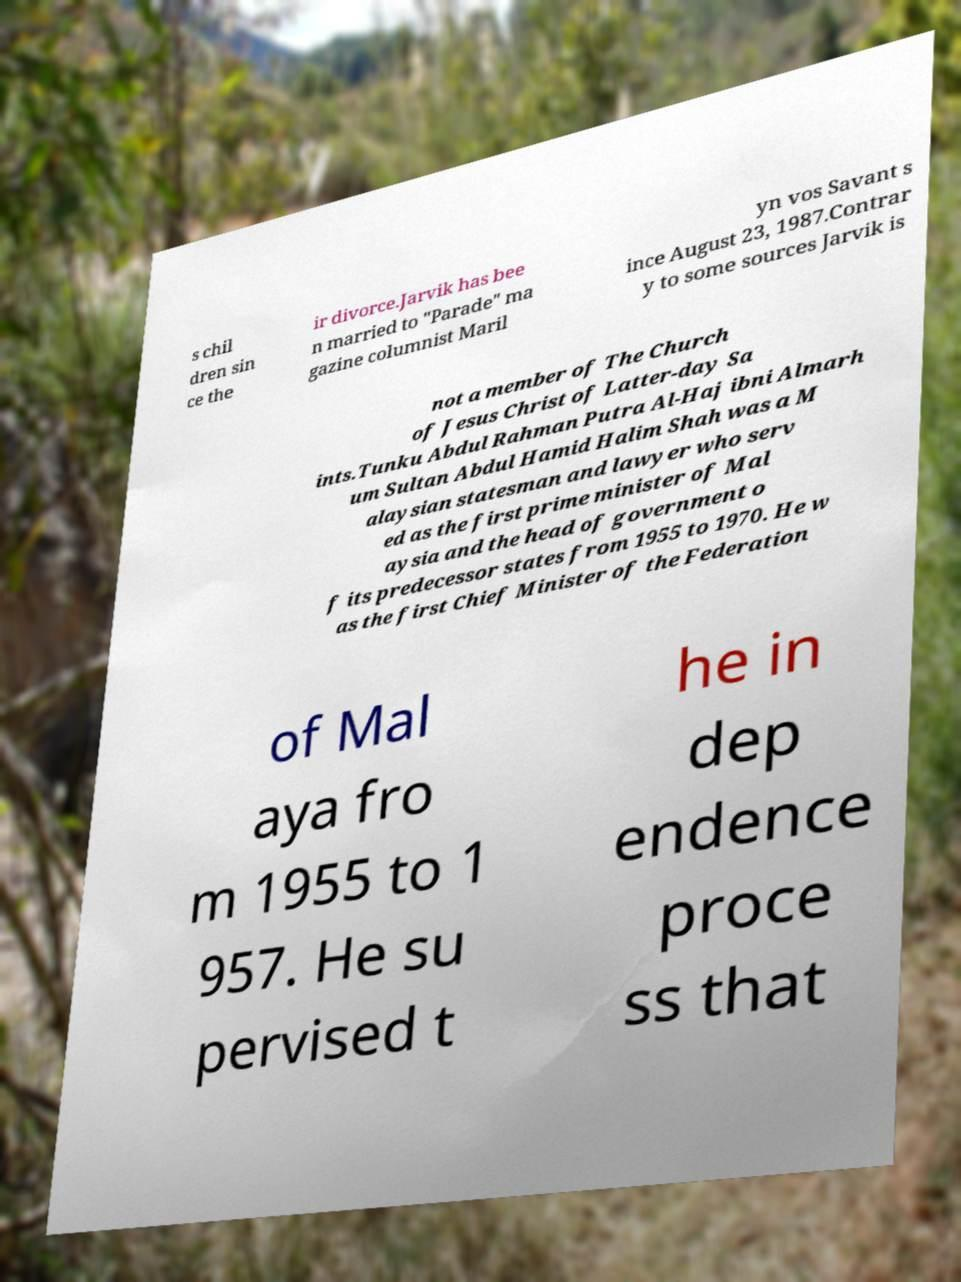Can you accurately transcribe the text from the provided image for me? s chil dren sin ce the ir divorce.Jarvik has bee n married to "Parade" ma gazine columnist Maril yn vos Savant s ince August 23, 1987.Contrar y to some sources Jarvik is not a member of The Church of Jesus Christ of Latter-day Sa ints.Tunku Abdul Rahman Putra Al-Haj ibni Almarh um Sultan Abdul Hamid Halim Shah was a M alaysian statesman and lawyer who serv ed as the first prime minister of Mal aysia and the head of government o f its predecessor states from 1955 to 1970. He w as the first Chief Minister of the Federation of Mal aya fro m 1955 to 1 957. He su pervised t he in dep endence proce ss that 